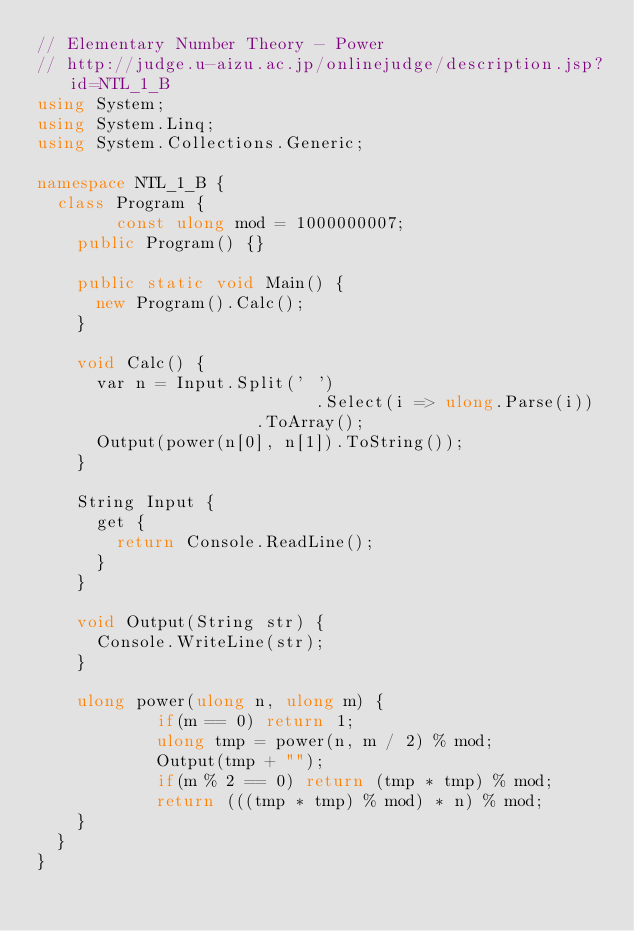<code> <loc_0><loc_0><loc_500><loc_500><_C#_>// Elementary Number Theory - Power
// http://judge.u-aizu.ac.jp/onlinejudge/description.jsp?id=NTL_1_B
using System;
using System.Linq;
using System.Collections.Generic;

namespace NTL_1_B {
	class Program {
        const ulong mod = 1000000007;
		public Program() {}
		
		public static void Main() {
			new Program().Calc();
		}
		
		void Calc() {
			var n = Input.Split(' ')
                            .Select(i => ulong.Parse(i))
			                .ToArray();
			Output(power(n[0], n[1]).ToString());
		}
		
		String Input {
			get {
				return Console.ReadLine();
			}
		}
		
		void Output(String str) {
			Console.WriteLine(str);
		}
		
		ulong power(ulong n, ulong m) {
            if(m == 0) return 1;
            ulong tmp = power(n, m / 2) % mod;
            Output(tmp + "");
            if(m % 2 == 0) return (tmp * tmp) % mod;
            return (((tmp * tmp) % mod) * n) % mod;
		}
	}
}</code> 